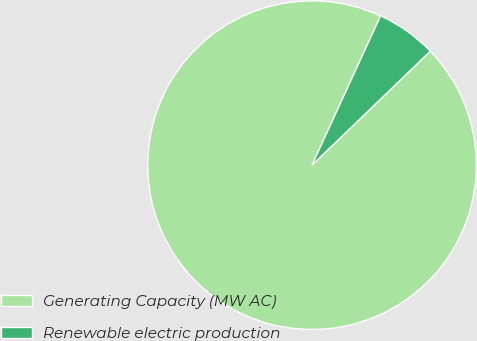<chart> <loc_0><loc_0><loc_500><loc_500><pie_chart><fcel>Generating Capacity (MW AC)<fcel>Renewable electric production<nl><fcel>94.06%<fcel>5.94%<nl></chart> 